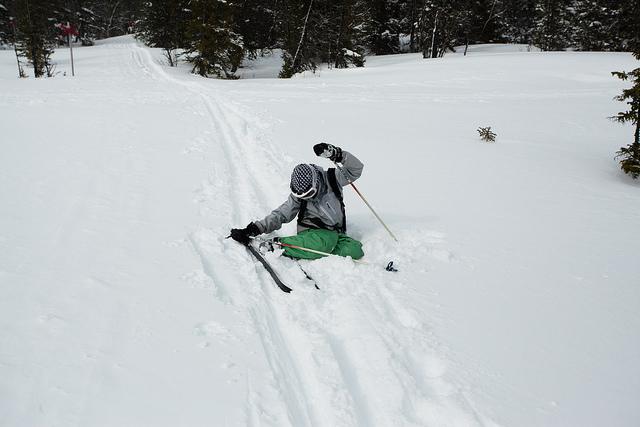Is the man ok?
Be succinct. Yes. Did this person fall down?
Answer briefly. Yes. Is this man snowboarding?
Be succinct. No. 